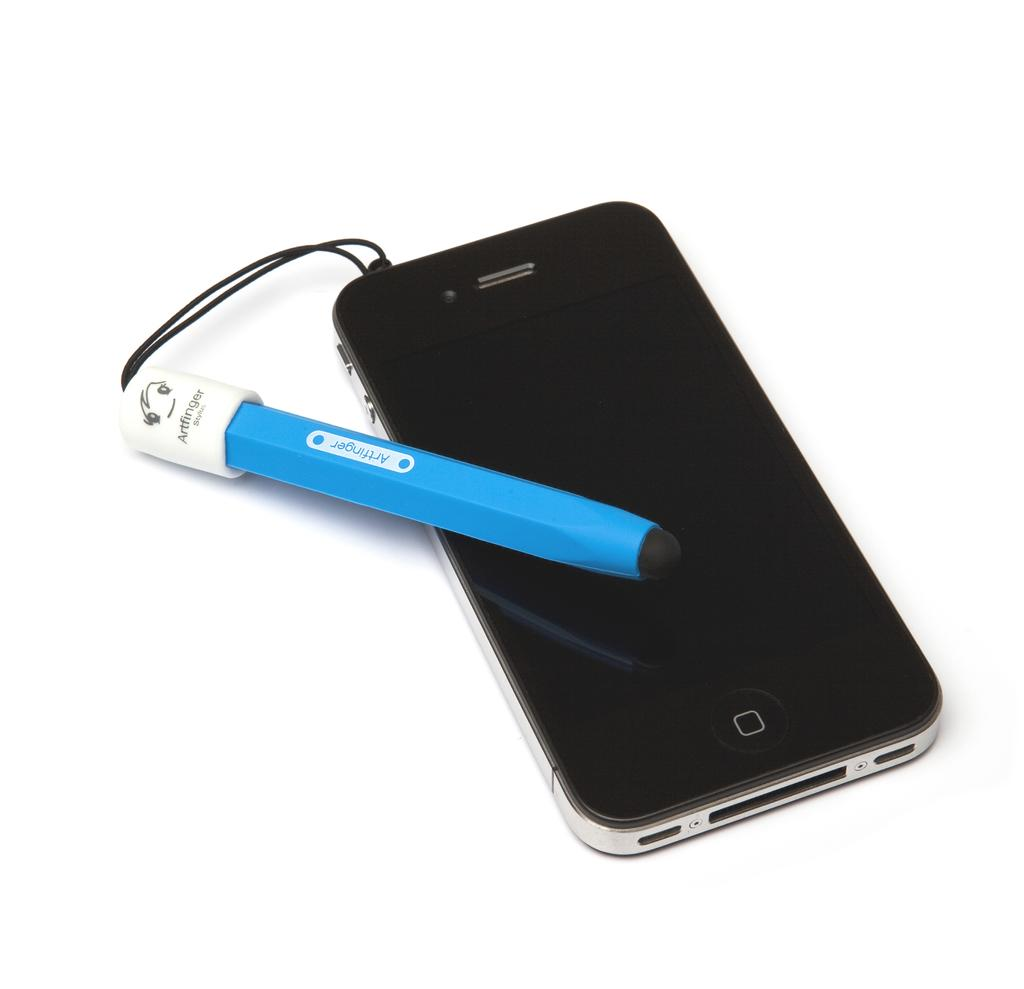<image>
Provide a brief description of the given image. A blue artfinger stylus is on the top of a smartphone. 